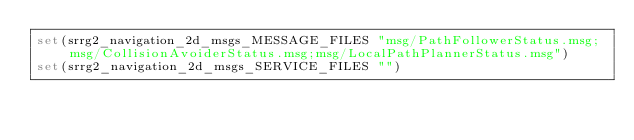<code> <loc_0><loc_0><loc_500><loc_500><_CMake_>set(srrg2_navigation_2d_msgs_MESSAGE_FILES "msg/PathFollowerStatus.msg;msg/CollisionAvoiderStatus.msg;msg/LocalPathPlannerStatus.msg")
set(srrg2_navigation_2d_msgs_SERVICE_FILES "")
</code> 